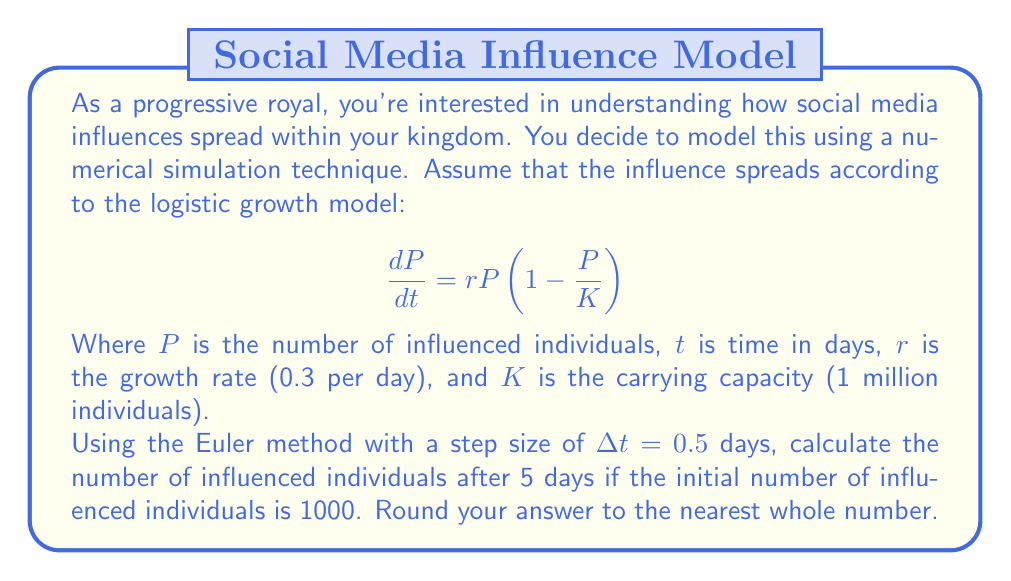What is the answer to this math problem? To solve this problem, we'll use the Euler method to numerically approximate the solution to the logistic growth differential equation.

1) The Euler method is given by:
   $$P_{n+1} = P_n + \Delta t \cdot f(t_n, P_n)$$
   where $f(t, P) = rP(1-\frac{P}{K})$

2) Given:
   - Initial population $P_0 = 1000$
   - Growth rate $r = 0.3$ per day
   - Carrying capacity $K = 1,000,000$
   - Step size $\Delta t = 0.5$ days
   - We need to calculate for 5 days, so we'll need 10 steps (5/0.5 = 10)

3) Let's calculate step by step:

   Step 0: $P_0 = 1000$
   
   Step 1: $P_1 = 1000 + 0.5 \cdot 0.3 \cdot 1000(1-\frac{1000}{1000000}) = 1149.85$
   
   Step 2: $P_2 = 1149.85 + 0.5 \cdot 0.3 \cdot 1149.85(1-\frac{1149.85}{1000000}) = 1321.33$
   
   Step 3: $P_3 = 1321.33 + 0.5 \cdot 0.3 \cdot 1321.33(1-\frac{1321.33}{1000000}) = 1517.73$
   
   ...

4) Continuing this process for 10 steps, we get:

   $P_{10} = 4051.62$

5) Rounding to the nearest whole number, we get 4052.
Answer: 4052 individuals 